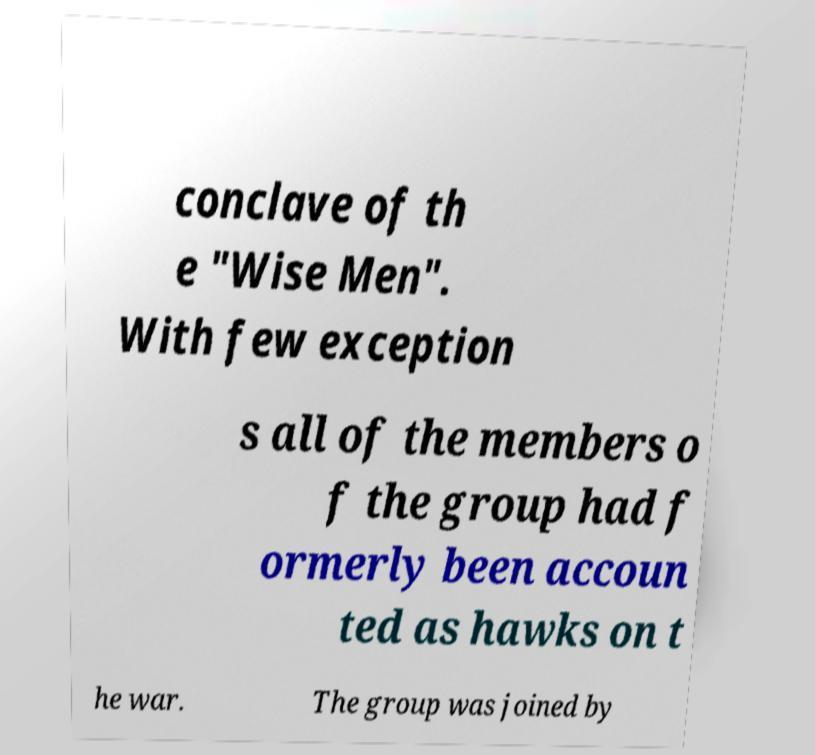Can you accurately transcribe the text from the provided image for me? conclave of th e "Wise Men". With few exception s all of the members o f the group had f ormerly been accoun ted as hawks on t he war. The group was joined by 